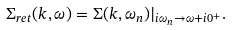<formula> <loc_0><loc_0><loc_500><loc_500>\Sigma _ { r e t } ( { k } , \omega ) = \Sigma ( { k } , \omega _ { n } ) | _ { i \omega _ { n } \rightarrow \omega + i 0 ^ { + } } .</formula> 